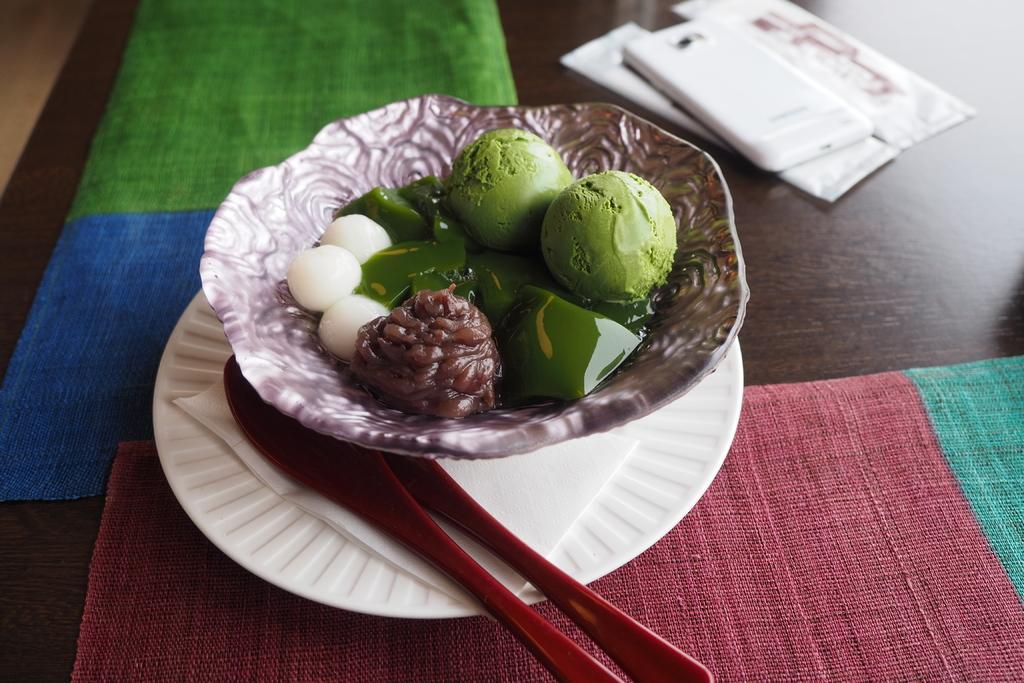Can you describe this image briefly? In this image we can see the bowl of ice cream and sweets. And we can see the plastic spoons. And we can see the mobile on the table. And we can see the napkins. 